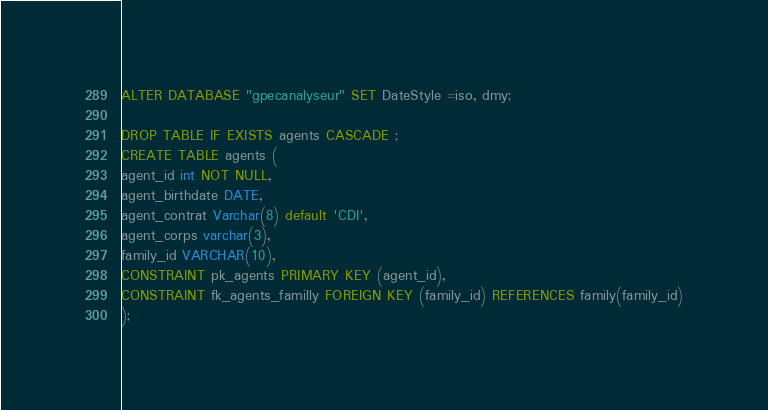<code> <loc_0><loc_0><loc_500><loc_500><_SQL_>ALTER DATABASE "gpecanalyseur" SET DateStyle =iso, dmy;

DROP TABLE IF EXISTS agents CASCADE ;
CREATE TABLE agents (
agent_id int NOT NULL,
agent_birthdate DATE,
agent_contrat Varchar(8) default 'CDI',
agent_corps varchar(3),
family_id VARCHAR(10),
CONSTRAINT pk_agents PRIMARY KEY (agent_id),
CONSTRAINT fk_agents_familly FOREIGN KEY (family_id) REFERENCES family(family_id)
);

</code> 